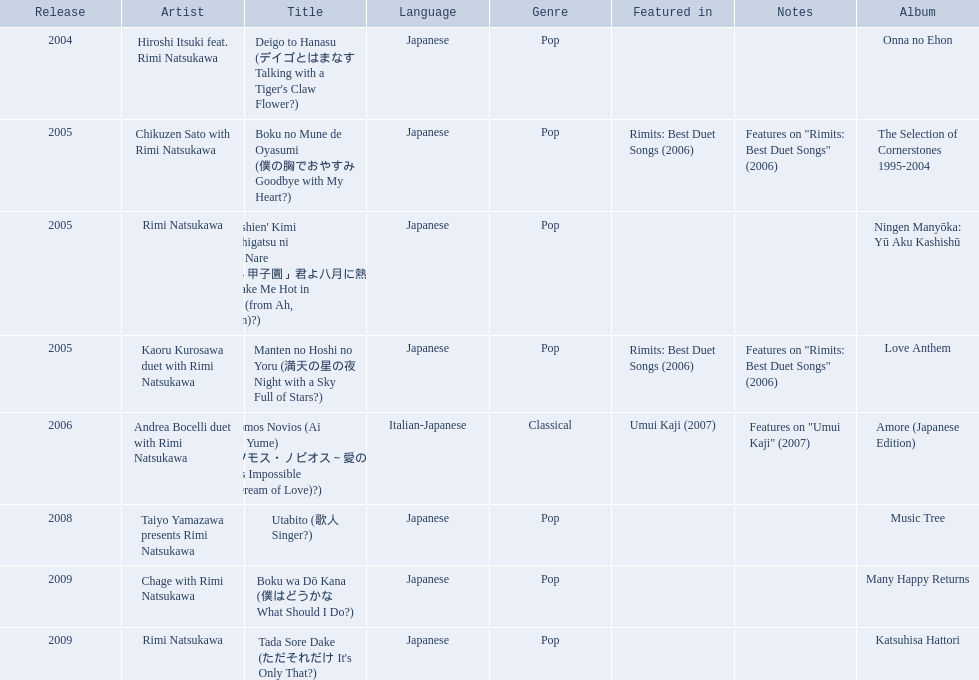What are all of the titles? Deigo to Hanasu (デイゴとはまなす Talking with a Tiger's Claw Flower?), Boku no Mune de Oyasumi (僕の胸でおやすみ Goodbye with My Heart?), 'Aa Kōshien' Kimi yo Hachigatsu ni Atsuku Nare (「あゝ甲子園」君よ八月に熱くなれ You Make Me Hot in August (from Ah, Kōshien)?), Manten no Hoshi no Yoru (満天の星の夜 Night with a Sky Full of Stars?), Somos Novios (Ai no Yume) (ソモス・ノビオス～愛の夢 It's Impossible (Dream of Love)?), Utabito (歌人 Singer?), Boku wa Dō Kana (僕はどうかな What Should I Do?), Tada Sore Dake (ただそれだけ It's Only That?). What are their notes? , Features on "Rimits: Best Duet Songs" (2006), , Features on "Rimits: Best Duet Songs" (2006), Features on "Umui Kaji" (2007), , , . Which title shares its notes with manten no hoshi no yoru (man tian noxing noye night with a sky full of stars?)? Boku no Mune de Oyasumi (僕の胸でおやすみ Goodbye with My Heart?). 